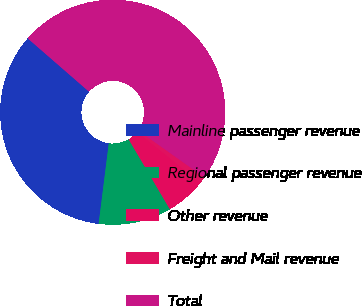Convert chart to OTSL. <chart><loc_0><loc_0><loc_500><loc_500><pie_chart><fcel>Mainline passenger revenue<fcel>Regional passenger revenue<fcel>Other revenue<fcel>Freight and Mail revenue<fcel>Total<nl><fcel>34.4%<fcel>10.47%<fcel>5.72%<fcel>0.97%<fcel>48.45%<nl></chart> 